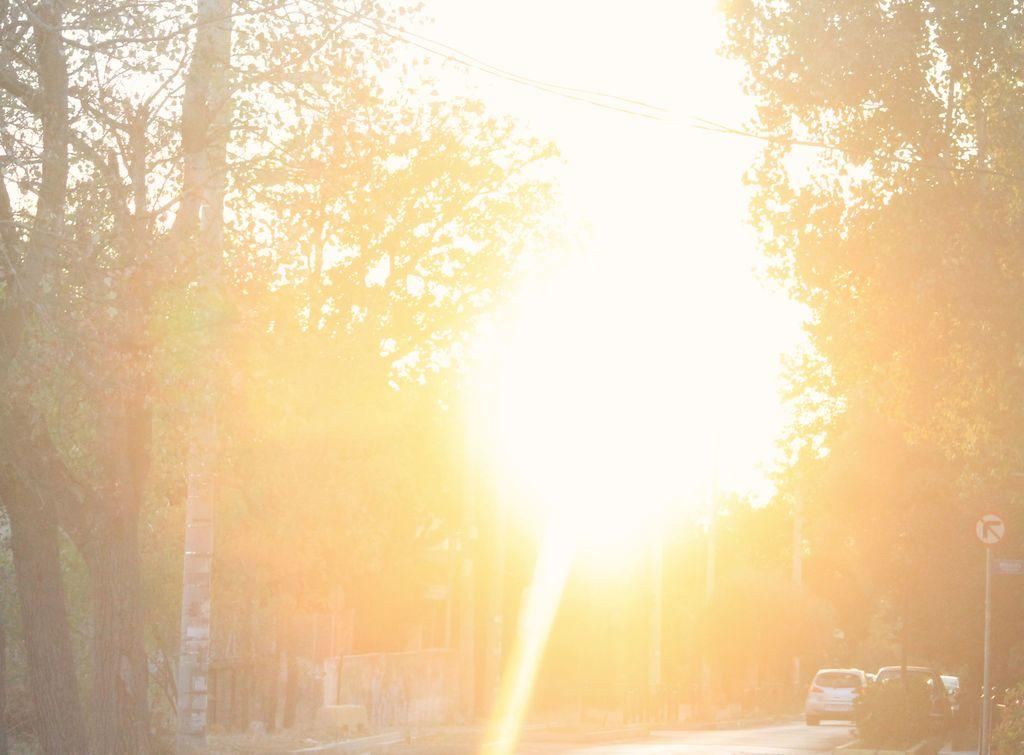What is happening on the road in the image? There are vehicles moving on the road in the image. What can be seen on the sides of the road? There are trees on both the right and left sides of the image. What is present to provide information or directions in the image? There is a signboard in the image. What is visible in the background of the image? The sky is visible in the background of the image. How does the wind affect the movement of the vehicles in the image? The image does not show any wind affecting the movement of the vehicles; the vehicles are moving on the road without any visible influence from the wind. 